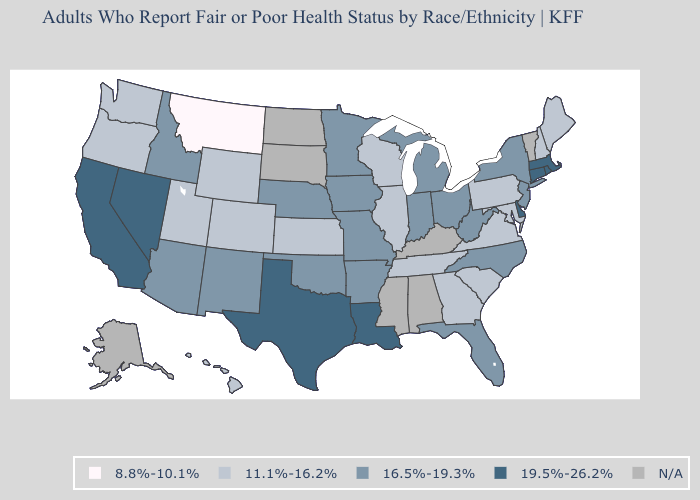Name the states that have a value in the range 19.5%-26.2%?
Write a very short answer. California, Connecticut, Delaware, Louisiana, Massachusetts, Nevada, Rhode Island, Texas. What is the highest value in the USA?
Keep it brief. 19.5%-26.2%. Does Montana have the lowest value in the West?
Quick response, please. Yes. What is the value of North Carolina?
Give a very brief answer. 16.5%-19.3%. Name the states that have a value in the range 16.5%-19.3%?
Short answer required. Arizona, Arkansas, Florida, Idaho, Indiana, Iowa, Michigan, Minnesota, Missouri, Nebraska, New Jersey, New Mexico, New York, North Carolina, Ohio, Oklahoma, West Virginia. What is the lowest value in the USA?
Concise answer only. 8.8%-10.1%. Among the states that border Missouri , which have the highest value?
Keep it brief. Arkansas, Iowa, Nebraska, Oklahoma. What is the highest value in the South ?
Keep it brief. 19.5%-26.2%. What is the value of South Dakota?
Short answer required. N/A. Does the first symbol in the legend represent the smallest category?
Give a very brief answer. Yes. Among the states that border South Carolina , does North Carolina have the highest value?
Quick response, please. Yes. Name the states that have a value in the range 19.5%-26.2%?
Keep it brief. California, Connecticut, Delaware, Louisiana, Massachusetts, Nevada, Rhode Island, Texas. Name the states that have a value in the range 16.5%-19.3%?
Be succinct. Arizona, Arkansas, Florida, Idaho, Indiana, Iowa, Michigan, Minnesota, Missouri, Nebraska, New Jersey, New Mexico, New York, North Carolina, Ohio, Oklahoma, West Virginia. Does the first symbol in the legend represent the smallest category?
Keep it brief. Yes. Does the first symbol in the legend represent the smallest category?
Be succinct. Yes. 